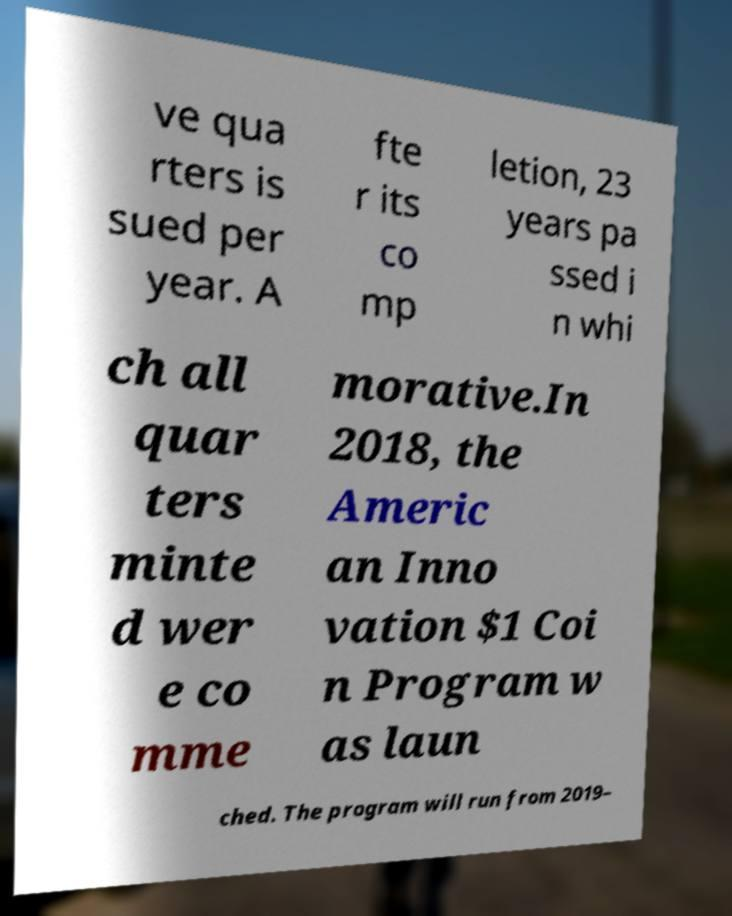There's text embedded in this image that I need extracted. Can you transcribe it verbatim? ve qua rters is sued per year. A fte r its co mp letion, 23 years pa ssed i n whi ch all quar ters minte d wer e co mme morative.In 2018, the Americ an Inno vation $1 Coi n Program w as laun ched. The program will run from 2019– 